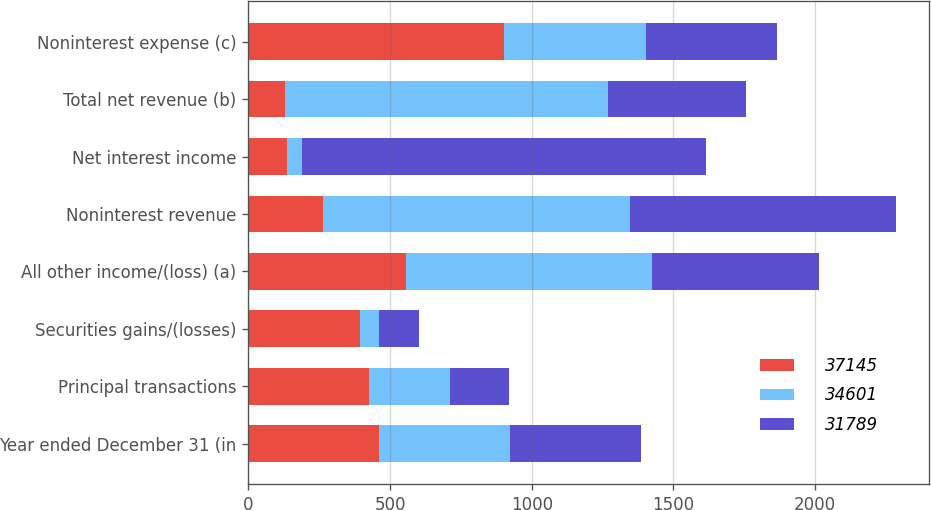Convert chart. <chart><loc_0><loc_0><loc_500><loc_500><stacked_bar_chart><ecel><fcel>Year ended December 31 (in<fcel>Principal transactions<fcel>Securities gains/(losses)<fcel>All other income/(loss) (a)<fcel>Noninterest revenue<fcel>Net interest income<fcel>Total net revenue (b)<fcel>Noninterest expense (c)<nl><fcel>37145<fcel>462<fcel>426<fcel>395<fcel>558<fcel>263<fcel>135<fcel>128<fcel>902<nl><fcel>34601<fcel>462<fcel>284<fcel>66<fcel>867<fcel>1085<fcel>55<fcel>1140<fcel>501<nl><fcel>31789<fcel>462<fcel>210<fcel>140<fcel>588<fcel>938<fcel>1425<fcel>487<fcel>462<nl></chart> 